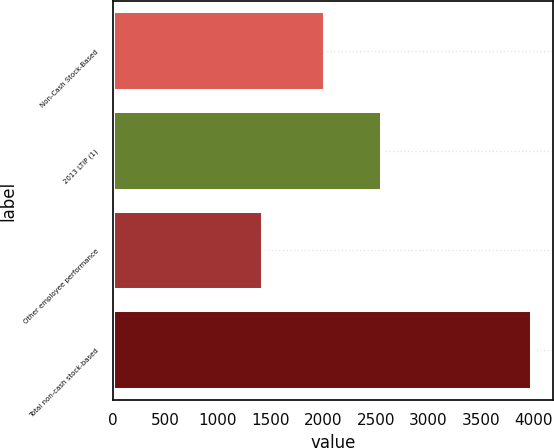Convert chart. <chart><loc_0><loc_0><loc_500><loc_500><bar_chart><fcel>Non-Cash Stock-Based<fcel>2013 LTIP (1)<fcel>Other employee performance<fcel>Total non-cash stock-based<nl><fcel>2016<fcel>2565<fcel>1424<fcel>3989<nl></chart> 